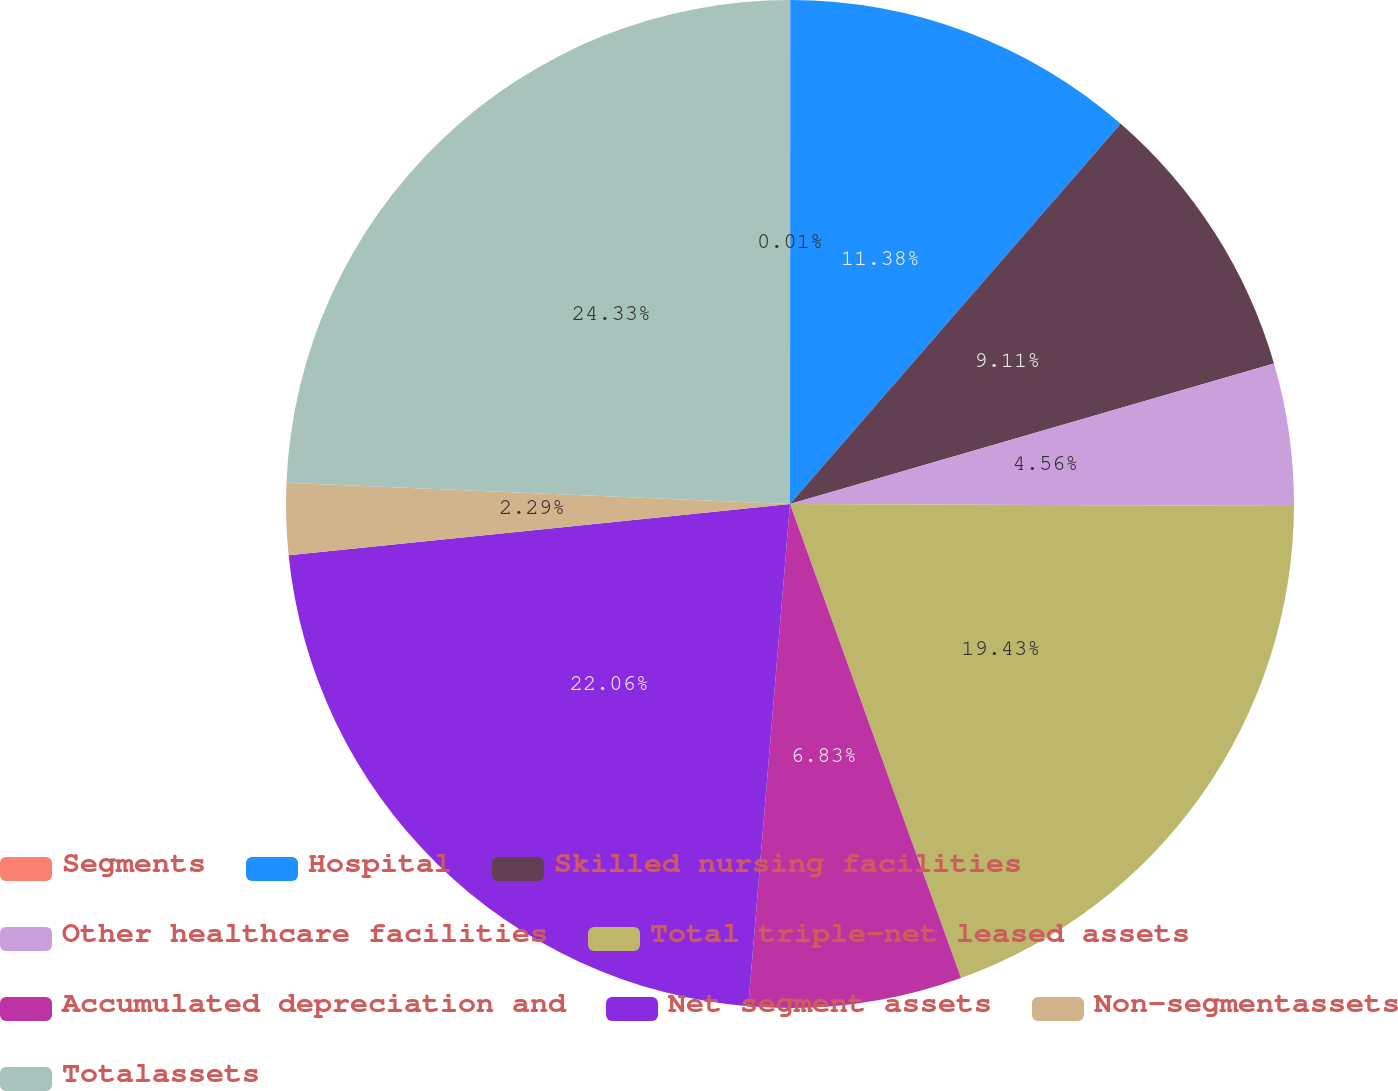Convert chart. <chart><loc_0><loc_0><loc_500><loc_500><pie_chart><fcel>Segments<fcel>Hospital<fcel>Skilled nursing facilities<fcel>Other healthcare facilities<fcel>Total triple-net leased assets<fcel>Accumulated depreciation and<fcel>Net segment assets<fcel>Non-segmentassets<fcel>Totalassets<nl><fcel>0.01%<fcel>11.38%<fcel>9.11%<fcel>4.56%<fcel>19.43%<fcel>6.83%<fcel>22.06%<fcel>2.29%<fcel>24.33%<nl></chart> 